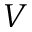Convert formula to latex. <formula><loc_0><loc_0><loc_500><loc_500>V</formula> 